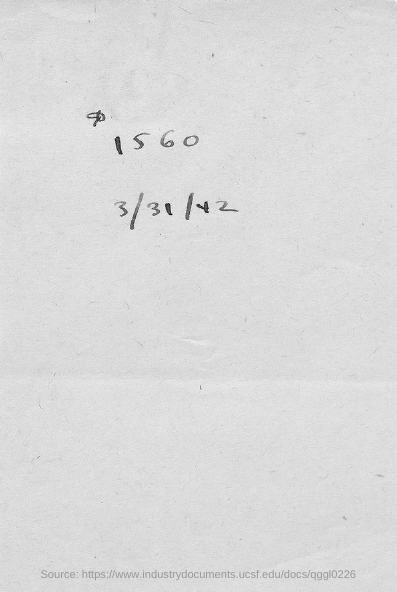What is the date mentioned in this document?
Give a very brief answer. 3/31/42. 